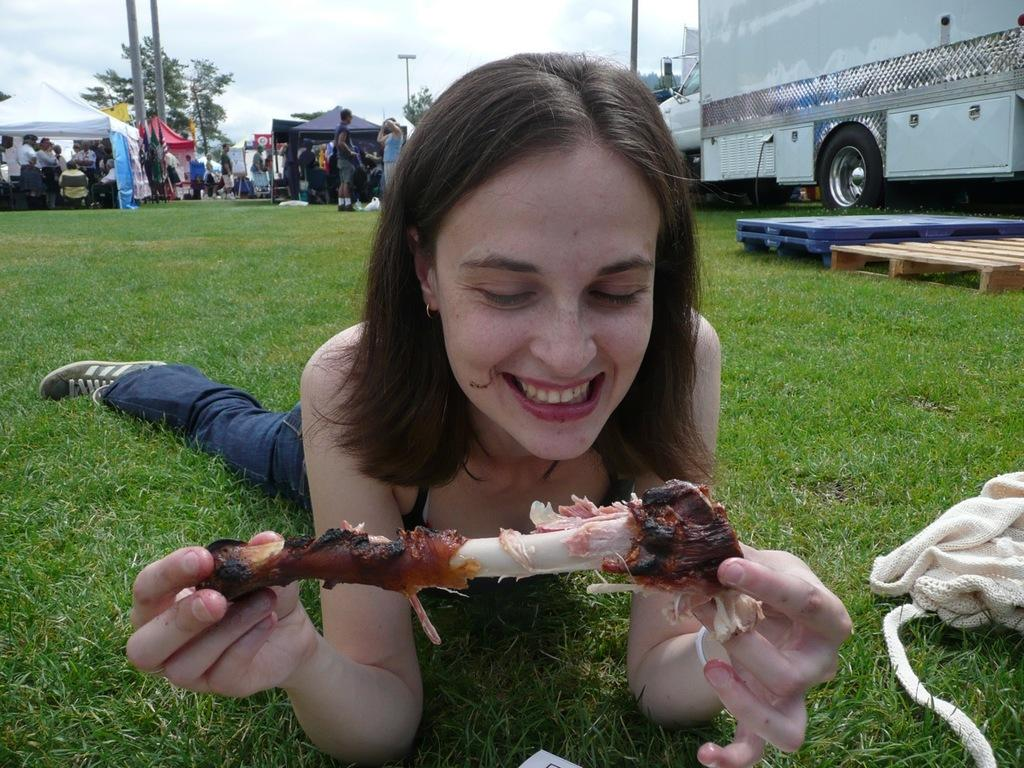What is the woman in the image doing? The woman is laying down in the image. What is the woman holding in the image? The woman is holding a bone. What is covering the grass in the image? There is cloth on the grass. What can be seen in the background of the image? In the background, there are people, a vehicle, tables, tents, poles, light, trees, and the sky. How many tomatoes are on the woman's plate in the image? There is no plate or tomatoes present in the image. What type of cub is playing with the woman in the image? There is no cub present in the image. 